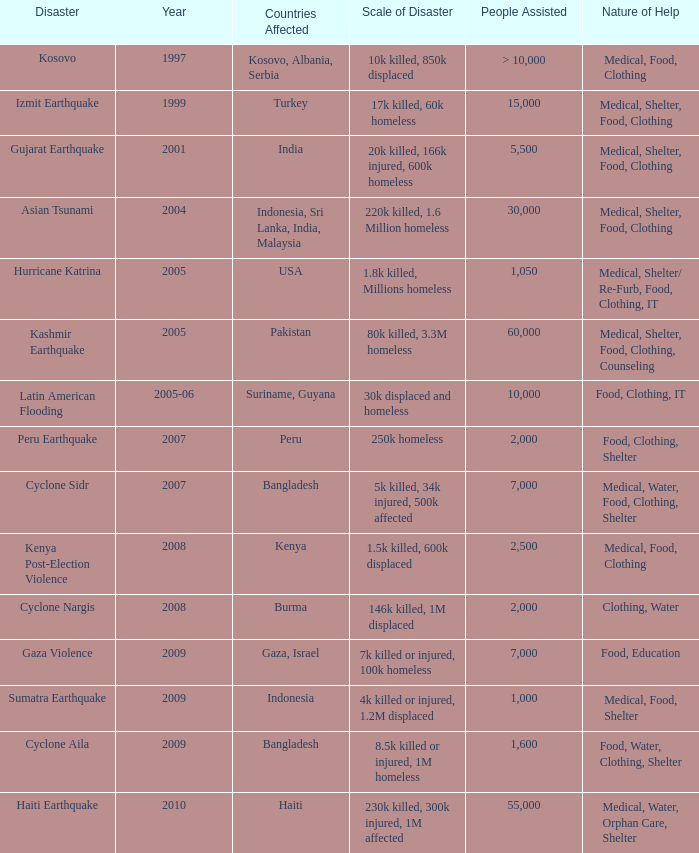Which year did USA undergo a disaster? 2005.0. 